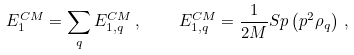<formula> <loc_0><loc_0><loc_500><loc_500>E ^ { C M } _ { 1 } = \sum _ { q } E ^ { C M } _ { 1 , q } \, , \quad E ^ { C M } _ { 1 , q } = \frac { 1 } { 2 M } S p \left ( { p } ^ { 2 } \rho _ { q } \right ) \, ,</formula> 